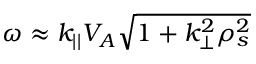Convert formula to latex. <formula><loc_0><loc_0><loc_500><loc_500>\omega \approx k _ { | | } V _ { A } \sqrt { 1 + k _ { \perp } ^ { 2 } \rho _ { s } ^ { 2 } }</formula> 